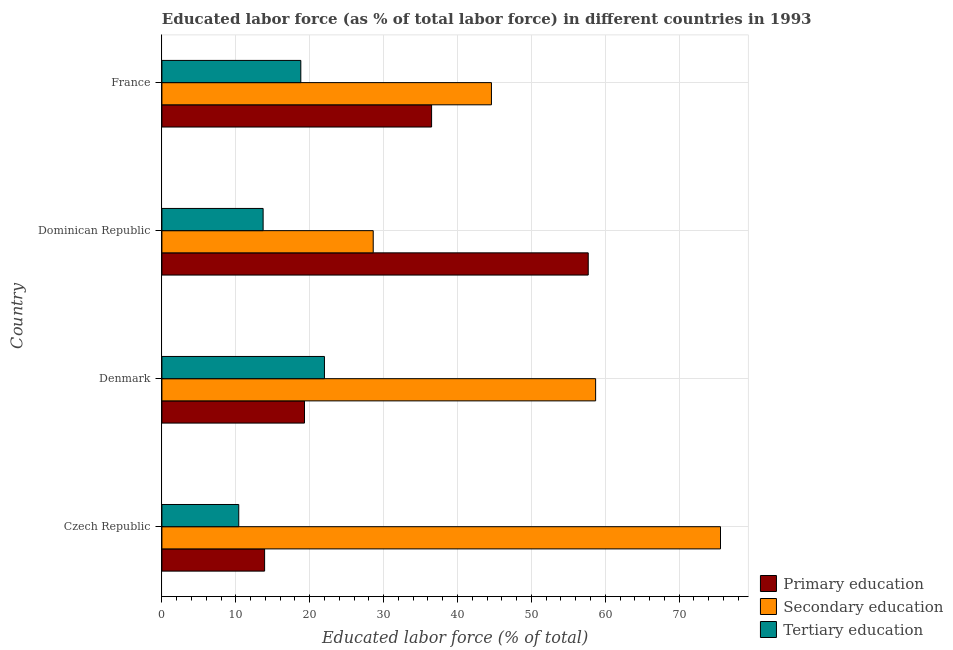Are the number of bars on each tick of the Y-axis equal?
Keep it short and to the point. Yes. How many bars are there on the 3rd tick from the top?
Ensure brevity in your answer.  3. In how many cases, is the number of bars for a given country not equal to the number of legend labels?
Provide a succinct answer. 0. What is the percentage of labor force who received primary education in Dominican Republic?
Give a very brief answer. 57.7. Across all countries, what is the maximum percentage of labor force who received secondary education?
Provide a succinct answer. 75.6. Across all countries, what is the minimum percentage of labor force who received primary education?
Make the answer very short. 13.9. In which country was the percentage of labor force who received secondary education maximum?
Make the answer very short. Czech Republic. In which country was the percentage of labor force who received tertiary education minimum?
Keep it short and to the point. Czech Republic. What is the total percentage of labor force who received tertiary education in the graph?
Offer a terse response. 64.9. What is the difference between the percentage of labor force who received tertiary education in Dominican Republic and the percentage of labor force who received primary education in France?
Your answer should be very brief. -22.8. What is the average percentage of labor force who received secondary education per country?
Your answer should be very brief. 51.88. What is the ratio of the percentage of labor force who received secondary education in Czech Republic to that in Denmark?
Your answer should be compact. 1.29. What is the difference between the highest and the second highest percentage of labor force who received secondary education?
Give a very brief answer. 16.9. What is the difference between the highest and the lowest percentage of labor force who received primary education?
Offer a very short reply. 43.8. What does the 1st bar from the top in Denmark represents?
Provide a succinct answer. Tertiary education. What does the 3rd bar from the bottom in Czech Republic represents?
Keep it short and to the point. Tertiary education. Is it the case that in every country, the sum of the percentage of labor force who received primary education and percentage of labor force who received secondary education is greater than the percentage of labor force who received tertiary education?
Your answer should be very brief. Yes. How many bars are there?
Offer a terse response. 12. How many countries are there in the graph?
Provide a succinct answer. 4. What is the difference between two consecutive major ticks on the X-axis?
Ensure brevity in your answer.  10. What is the title of the graph?
Provide a succinct answer. Educated labor force (as % of total labor force) in different countries in 1993. What is the label or title of the X-axis?
Your answer should be very brief. Educated labor force (% of total). What is the Educated labor force (% of total) of Primary education in Czech Republic?
Provide a succinct answer. 13.9. What is the Educated labor force (% of total) in Secondary education in Czech Republic?
Keep it short and to the point. 75.6. What is the Educated labor force (% of total) of Tertiary education in Czech Republic?
Your response must be concise. 10.4. What is the Educated labor force (% of total) in Primary education in Denmark?
Keep it short and to the point. 19.3. What is the Educated labor force (% of total) of Secondary education in Denmark?
Keep it short and to the point. 58.7. What is the Educated labor force (% of total) in Primary education in Dominican Republic?
Your response must be concise. 57.7. What is the Educated labor force (% of total) of Secondary education in Dominican Republic?
Give a very brief answer. 28.6. What is the Educated labor force (% of total) of Tertiary education in Dominican Republic?
Your response must be concise. 13.7. What is the Educated labor force (% of total) of Primary education in France?
Keep it short and to the point. 36.5. What is the Educated labor force (% of total) of Secondary education in France?
Your answer should be compact. 44.6. What is the Educated labor force (% of total) in Tertiary education in France?
Your answer should be very brief. 18.8. Across all countries, what is the maximum Educated labor force (% of total) in Primary education?
Give a very brief answer. 57.7. Across all countries, what is the maximum Educated labor force (% of total) in Secondary education?
Your answer should be very brief. 75.6. Across all countries, what is the maximum Educated labor force (% of total) of Tertiary education?
Ensure brevity in your answer.  22. Across all countries, what is the minimum Educated labor force (% of total) in Primary education?
Your answer should be very brief. 13.9. Across all countries, what is the minimum Educated labor force (% of total) of Secondary education?
Provide a short and direct response. 28.6. Across all countries, what is the minimum Educated labor force (% of total) in Tertiary education?
Provide a short and direct response. 10.4. What is the total Educated labor force (% of total) in Primary education in the graph?
Keep it short and to the point. 127.4. What is the total Educated labor force (% of total) of Secondary education in the graph?
Provide a succinct answer. 207.5. What is the total Educated labor force (% of total) of Tertiary education in the graph?
Offer a very short reply. 64.9. What is the difference between the Educated labor force (% of total) of Primary education in Czech Republic and that in Denmark?
Your response must be concise. -5.4. What is the difference between the Educated labor force (% of total) in Tertiary education in Czech Republic and that in Denmark?
Ensure brevity in your answer.  -11.6. What is the difference between the Educated labor force (% of total) of Primary education in Czech Republic and that in Dominican Republic?
Your answer should be compact. -43.8. What is the difference between the Educated labor force (% of total) of Primary education in Czech Republic and that in France?
Keep it short and to the point. -22.6. What is the difference between the Educated labor force (% of total) in Secondary education in Czech Republic and that in France?
Your response must be concise. 31. What is the difference between the Educated labor force (% of total) of Tertiary education in Czech Republic and that in France?
Offer a terse response. -8.4. What is the difference between the Educated labor force (% of total) of Primary education in Denmark and that in Dominican Republic?
Your answer should be compact. -38.4. What is the difference between the Educated labor force (% of total) in Secondary education in Denmark and that in Dominican Republic?
Keep it short and to the point. 30.1. What is the difference between the Educated labor force (% of total) of Tertiary education in Denmark and that in Dominican Republic?
Offer a very short reply. 8.3. What is the difference between the Educated labor force (% of total) of Primary education in Denmark and that in France?
Provide a short and direct response. -17.2. What is the difference between the Educated labor force (% of total) in Secondary education in Denmark and that in France?
Provide a short and direct response. 14.1. What is the difference between the Educated labor force (% of total) of Primary education in Dominican Republic and that in France?
Ensure brevity in your answer.  21.2. What is the difference between the Educated labor force (% of total) of Tertiary education in Dominican Republic and that in France?
Provide a short and direct response. -5.1. What is the difference between the Educated labor force (% of total) of Primary education in Czech Republic and the Educated labor force (% of total) of Secondary education in Denmark?
Your answer should be very brief. -44.8. What is the difference between the Educated labor force (% of total) of Secondary education in Czech Republic and the Educated labor force (% of total) of Tertiary education in Denmark?
Give a very brief answer. 53.6. What is the difference between the Educated labor force (% of total) in Primary education in Czech Republic and the Educated labor force (% of total) in Secondary education in Dominican Republic?
Ensure brevity in your answer.  -14.7. What is the difference between the Educated labor force (% of total) in Secondary education in Czech Republic and the Educated labor force (% of total) in Tertiary education in Dominican Republic?
Make the answer very short. 61.9. What is the difference between the Educated labor force (% of total) of Primary education in Czech Republic and the Educated labor force (% of total) of Secondary education in France?
Your response must be concise. -30.7. What is the difference between the Educated labor force (% of total) in Secondary education in Czech Republic and the Educated labor force (% of total) in Tertiary education in France?
Your response must be concise. 56.8. What is the difference between the Educated labor force (% of total) of Primary education in Denmark and the Educated labor force (% of total) of Tertiary education in Dominican Republic?
Give a very brief answer. 5.6. What is the difference between the Educated labor force (% of total) of Secondary education in Denmark and the Educated labor force (% of total) of Tertiary education in Dominican Republic?
Give a very brief answer. 45. What is the difference between the Educated labor force (% of total) in Primary education in Denmark and the Educated labor force (% of total) in Secondary education in France?
Offer a terse response. -25.3. What is the difference between the Educated labor force (% of total) in Primary education in Denmark and the Educated labor force (% of total) in Tertiary education in France?
Your response must be concise. 0.5. What is the difference between the Educated labor force (% of total) of Secondary education in Denmark and the Educated labor force (% of total) of Tertiary education in France?
Provide a short and direct response. 39.9. What is the difference between the Educated labor force (% of total) in Primary education in Dominican Republic and the Educated labor force (% of total) in Secondary education in France?
Ensure brevity in your answer.  13.1. What is the difference between the Educated labor force (% of total) of Primary education in Dominican Republic and the Educated labor force (% of total) of Tertiary education in France?
Offer a terse response. 38.9. What is the average Educated labor force (% of total) in Primary education per country?
Offer a very short reply. 31.85. What is the average Educated labor force (% of total) in Secondary education per country?
Provide a short and direct response. 51.88. What is the average Educated labor force (% of total) of Tertiary education per country?
Offer a terse response. 16.23. What is the difference between the Educated labor force (% of total) in Primary education and Educated labor force (% of total) in Secondary education in Czech Republic?
Make the answer very short. -61.7. What is the difference between the Educated labor force (% of total) of Primary education and Educated labor force (% of total) of Tertiary education in Czech Republic?
Keep it short and to the point. 3.5. What is the difference between the Educated labor force (% of total) of Secondary education and Educated labor force (% of total) of Tertiary education in Czech Republic?
Keep it short and to the point. 65.2. What is the difference between the Educated labor force (% of total) in Primary education and Educated labor force (% of total) in Secondary education in Denmark?
Your response must be concise. -39.4. What is the difference between the Educated labor force (% of total) in Secondary education and Educated labor force (% of total) in Tertiary education in Denmark?
Offer a terse response. 36.7. What is the difference between the Educated labor force (% of total) of Primary education and Educated labor force (% of total) of Secondary education in Dominican Republic?
Your answer should be compact. 29.1. What is the difference between the Educated labor force (% of total) in Primary education and Educated labor force (% of total) in Tertiary education in Dominican Republic?
Your answer should be compact. 44. What is the difference between the Educated labor force (% of total) of Primary education and Educated labor force (% of total) of Secondary education in France?
Provide a succinct answer. -8.1. What is the difference between the Educated labor force (% of total) in Primary education and Educated labor force (% of total) in Tertiary education in France?
Your answer should be compact. 17.7. What is the difference between the Educated labor force (% of total) of Secondary education and Educated labor force (% of total) of Tertiary education in France?
Make the answer very short. 25.8. What is the ratio of the Educated labor force (% of total) in Primary education in Czech Republic to that in Denmark?
Offer a terse response. 0.72. What is the ratio of the Educated labor force (% of total) in Secondary education in Czech Republic to that in Denmark?
Offer a terse response. 1.29. What is the ratio of the Educated labor force (% of total) in Tertiary education in Czech Republic to that in Denmark?
Keep it short and to the point. 0.47. What is the ratio of the Educated labor force (% of total) of Primary education in Czech Republic to that in Dominican Republic?
Provide a short and direct response. 0.24. What is the ratio of the Educated labor force (% of total) of Secondary education in Czech Republic to that in Dominican Republic?
Keep it short and to the point. 2.64. What is the ratio of the Educated labor force (% of total) in Tertiary education in Czech Republic to that in Dominican Republic?
Ensure brevity in your answer.  0.76. What is the ratio of the Educated labor force (% of total) in Primary education in Czech Republic to that in France?
Ensure brevity in your answer.  0.38. What is the ratio of the Educated labor force (% of total) in Secondary education in Czech Republic to that in France?
Your response must be concise. 1.7. What is the ratio of the Educated labor force (% of total) in Tertiary education in Czech Republic to that in France?
Make the answer very short. 0.55. What is the ratio of the Educated labor force (% of total) of Primary education in Denmark to that in Dominican Republic?
Provide a succinct answer. 0.33. What is the ratio of the Educated labor force (% of total) in Secondary education in Denmark to that in Dominican Republic?
Provide a short and direct response. 2.05. What is the ratio of the Educated labor force (% of total) of Tertiary education in Denmark to that in Dominican Republic?
Your answer should be compact. 1.61. What is the ratio of the Educated labor force (% of total) in Primary education in Denmark to that in France?
Make the answer very short. 0.53. What is the ratio of the Educated labor force (% of total) in Secondary education in Denmark to that in France?
Give a very brief answer. 1.32. What is the ratio of the Educated labor force (% of total) of Tertiary education in Denmark to that in France?
Your answer should be compact. 1.17. What is the ratio of the Educated labor force (% of total) of Primary education in Dominican Republic to that in France?
Your response must be concise. 1.58. What is the ratio of the Educated labor force (% of total) in Secondary education in Dominican Republic to that in France?
Make the answer very short. 0.64. What is the ratio of the Educated labor force (% of total) in Tertiary education in Dominican Republic to that in France?
Ensure brevity in your answer.  0.73. What is the difference between the highest and the second highest Educated labor force (% of total) of Primary education?
Give a very brief answer. 21.2. What is the difference between the highest and the lowest Educated labor force (% of total) in Primary education?
Offer a terse response. 43.8. What is the difference between the highest and the lowest Educated labor force (% of total) of Secondary education?
Offer a terse response. 47. What is the difference between the highest and the lowest Educated labor force (% of total) in Tertiary education?
Your response must be concise. 11.6. 